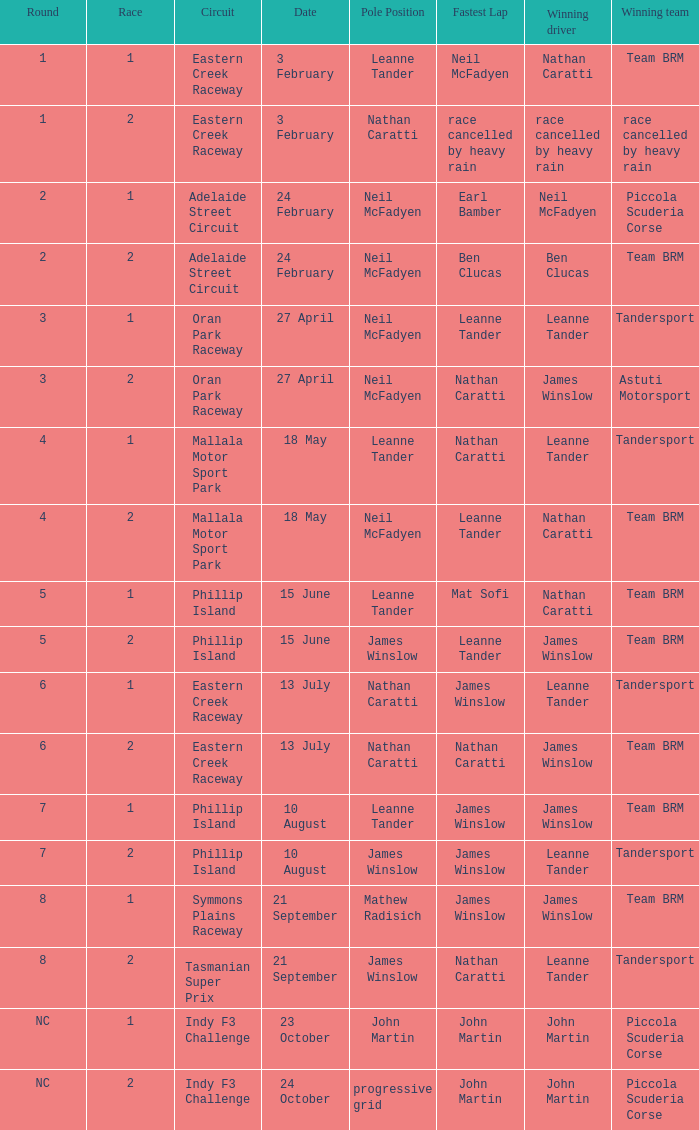What is the highest race number in the Phillip Island circuit with James Winslow as the winning driver and pole position? 2.0. 